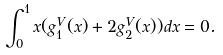Convert formula to latex. <formula><loc_0><loc_0><loc_500><loc_500>\int _ { 0 } ^ { 1 } x ( g _ { 1 } ^ { V } ( x ) + 2 g _ { 2 } ^ { V } ( x ) ) d x = 0 .</formula> 